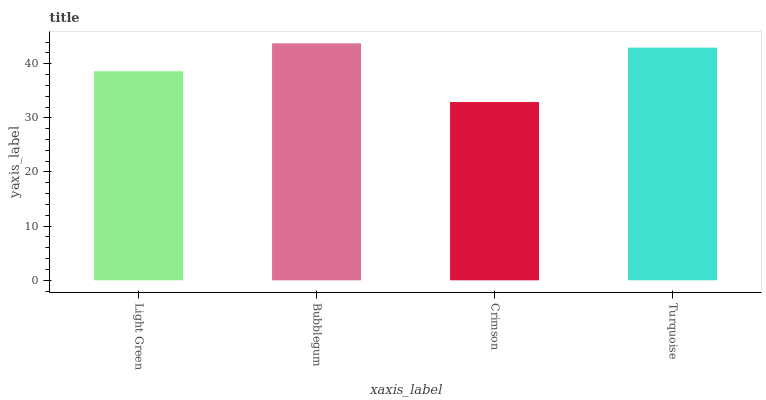Is Crimson the minimum?
Answer yes or no. Yes. Is Bubblegum the maximum?
Answer yes or no. Yes. Is Bubblegum the minimum?
Answer yes or no. No. Is Crimson the maximum?
Answer yes or no. No. Is Bubblegum greater than Crimson?
Answer yes or no. Yes. Is Crimson less than Bubblegum?
Answer yes or no. Yes. Is Crimson greater than Bubblegum?
Answer yes or no. No. Is Bubblegum less than Crimson?
Answer yes or no. No. Is Turquoise the high median?
Answer yes or no. Yes. Is Light Green the low median?
Answer yes or no. Yes. Is Bubblegum the high median?
Answer yes or no. No. Is Crimson the low median?
Answer yes or no. No. 